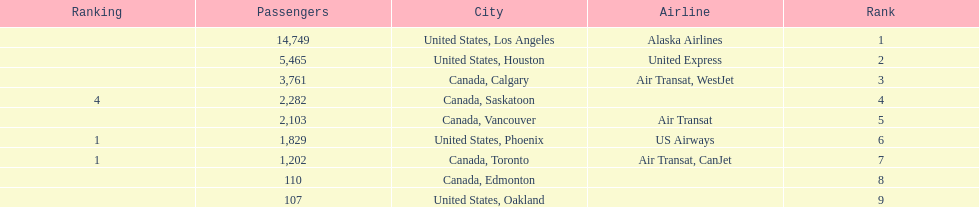How many cities from canada are on this list? 5. 